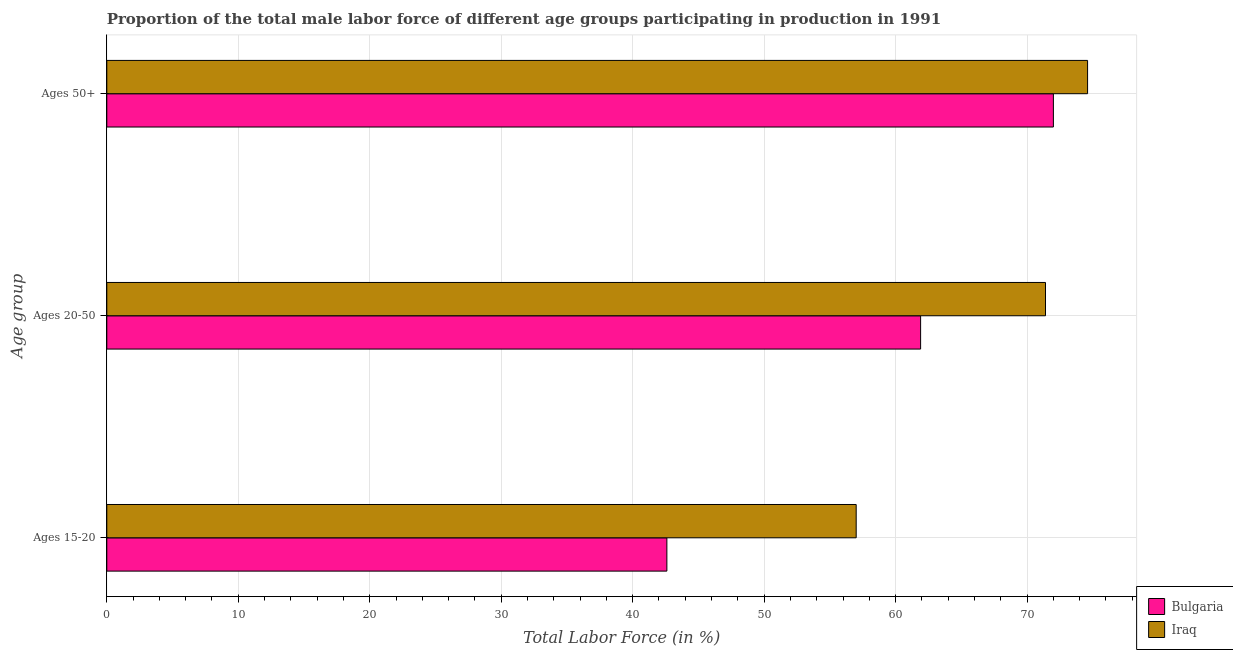How many groups of bars are there?
Your answer should be compact. 3. What is the label of the 1st group of bars from the top?
Ensure brevity in your answer.  Ages 50+. What is the percentage of male labor force within the age group 15-20 in Iraq?
Your answer should be compact. 57. Across all countries, what is the maximum percentage of male labor force above age 50?
Keep it short and to the point. 74.6. Across all countries, what is the minimum percentage of male labor force within the age group 20-50?
Make the answer very short. 61.9. In which country was the percentage of male labor force within the age group 15-20 maximum?
Give a very brief answer. Iraq. What is the total percentage of male labor force within the age group 15-20 in the graph?
Make the answer very short. 99.6. What is the difference between the percentage of male labor force within the age group 15-20 in Bulgaria and that in Iraq?
Provide a succinct answer. -14.4. What is the difference between the percentage of male labor force within the age group 20-50 in Iraq and the percentage of male labor force within the age group 15-20 in Bulgaria?
Ensure brevity in your answer.  28.8. What is the average percentage of male labor force within the age group 15-20 per country?
Provide a short and direct response. 49.8. What is the difference between the percentage of male labor force within the age group 15-20 and percentage of male labor force within the age group 20-50 in Iraq?
Provide a short and direct response. -14.4. What is the ratio of the percentage of male labor force above age 50 in Bulgaria to that in Iraq?
Your response must be concise. 0.97. What is the difference between the highest and the second highest percentage of male labor force above age 50?
Provide a short and direct response. 2.6. What is the difference between the highest and the lowest percentage of male labor force within the age group 15-20?
Make the answer very short. 14.4. Is the sum of the percentage of male labor force above age 50 in Bulgaria and Iraq greater than the maximum percentage of male labor force within the age group 15-20 across all countries?
Your answer should be compact. Yes. What does the 2nd bar from the top in Ages 50+ represents?
Offer a very short reply. Bulgaria. What does the 2nd bar from the bottom in Ages 15-20 represents?
Your answer should be compact. Iraq. Is it the case that in every country, the sum of the percentage of male labor force within the age group 15-20 and percentage of male labor force within the age group 20-50 is greater than the percentage of male labor force above age 50?
Provide a succinct answer. Yes. How many bars are there?
Your response must be concise. 6. Are all the bars in the graph horizontal?
Give a very brief answer. Yes. How many countries are there in the graph?
Offer a very short reply. 2. What is the difference between two consecutive major ticks on the X-axis?
Ensure brevity in your answer.  10. Are the values on the major ticks of X-axis written in scientific E-notation?
Provide a short and direct response. No. How many legend labels are there?
Give a very brief answer. 2. How are the legend labels stacked?
Your answer should be compact. Vertical. What is the title of the graph?
Offer a very short reply. Proportion of the total male labor force of different age groups participating in production in 1991. What is the label or title of the Y-axis?
Your answer should be very brief. Age group. What is the Total Labor Force (in %) in Bulgaria in Ages 15-20?
Offer a very short reply. 42.6. What is the Total Labor Force (in %) of Iraq in Ages 15-20?
Give a very brief answer. 57. What is the Total Labor Force (in %) of Bulgaria in Ages 20-50?
Offer a terse response. 61.9. What is the Total Labor Force (in %) of Iraq in Ages 20-50?
Give a very brief answer. 71.4. What is the Total Labor Force (in %) in Bulgaria in Ages 50+?
Provide a succinct answer. 72. What is the Total Labor Force (in %) of Iraq in Ages 50+?
Provide a succinct answer. 74.6. Across all Age group, what is the maximum Total Labor Force (in %) in Iraq?
Make the answer very short. 74.6. Across all Age group, what is the minimum Total Labor Force (in %) of Bulgaria?
Make the answer very short. 42.6. What is the total Total Labor Force (in %) in Bulgaria in the graph?
Your answer should be compact. 176.5. What is the total Total Labor Force (in %) in Iraq in the graph?
Keep it short and to the point. 203. What is the difference between the Total Labor Force (in %) in Bulgaria in Ages 15-20 and that in Ages 20-50?
Your answer should be very brief. -19.3. What is the difference between the Total Labor Force (in %) of Iraq in Ages 15-20 and that in Ages 20-50?
Ensure brevity in your answer.  -14.4. What is the difference between the Total Labor Force (in %) of Bulgaria in Ages 15-20 and that in Ages 50+?
Your answer should be compact. -29.4. What is the difference between the Total Labor Force (in %) of Iraq in Ages 15-20 and that in Ages 50+?
Your answer should be very brief. -17.6. What is the difference between the Total Labor Force (in %) in Bulgaria in Ages 20-50 and that in Ages 50+?
Your response must be concise. -10.1. What is the difference between the Total Labor Force (in %) in Bulgaria in Ages 15-20 and the Total Labor Force (in %) in Iraq in Ages 20-50?
Provide a short and direct response. -28.8. What is the difference between the Total Labor Force (in %) in Bulgaria in Ages 15-20 and the Total Labor Force (in %) in Iraq in Ages 50+?
Make the answer very short. -32. What is the average Total Labor Force (in %) of Bulgaria per Age group?
Make the answer very short. 58.83. What is the average Total Labor Force (in %) of Iraq per Age group?
Your response must be concise. 67.67. What is the difference between the Total Labor Force (in %) in Bulgaria and Total Labor Force (in %) in Iraq in Ages 15-20?
Give a very brief answer. -14.4. What is the difference between the Total Labor Force (in %) in Bulgaria and Total Labor Force (in %) in Iraq in Ages 20-50?
Give a very brief answer. -9.5. What is the ratio of the Total Labor Force (in %) in Bulgaria in Ages 15-20 to that in Ages 20-50?
Give a very brief answer. 0.69. What is the ratio of the Total Labor Force (in %) of Iraq in Ages 15-20 to that in Ages 20-50?
Offer a very short reply. 0.8. What is the ratio of the Total Labor Force (in %) of Bulgaria in Ages 15-20 to that in Ages 50+?
Keep it short and to the point. 0.59. What is the ratio of the Total Labor Force (in %) in Iraq in Ages 15-20 to that in Ages 50+?
Your response must be concise. 0.76. What is the ratio of the Total Labor Force (in %) of Bulgaria in Ages 20-50 to that in Ages 50+?
Your answer should be compact. 0.86. What is the ratio of the Total Labor Force (in %) in Iraq in Ages 20-50 to that in Ages 50+?
Your answer should be compact. 0.96. What is the difference between the highest and the second highest Total Labor Force (in %) in Iraq?
Your response must be concise. 3.2. What is the difference between the highest and the lowest Total Labor Force (in %) in Bulgaria?
Give a very brief answer. 29.4. 